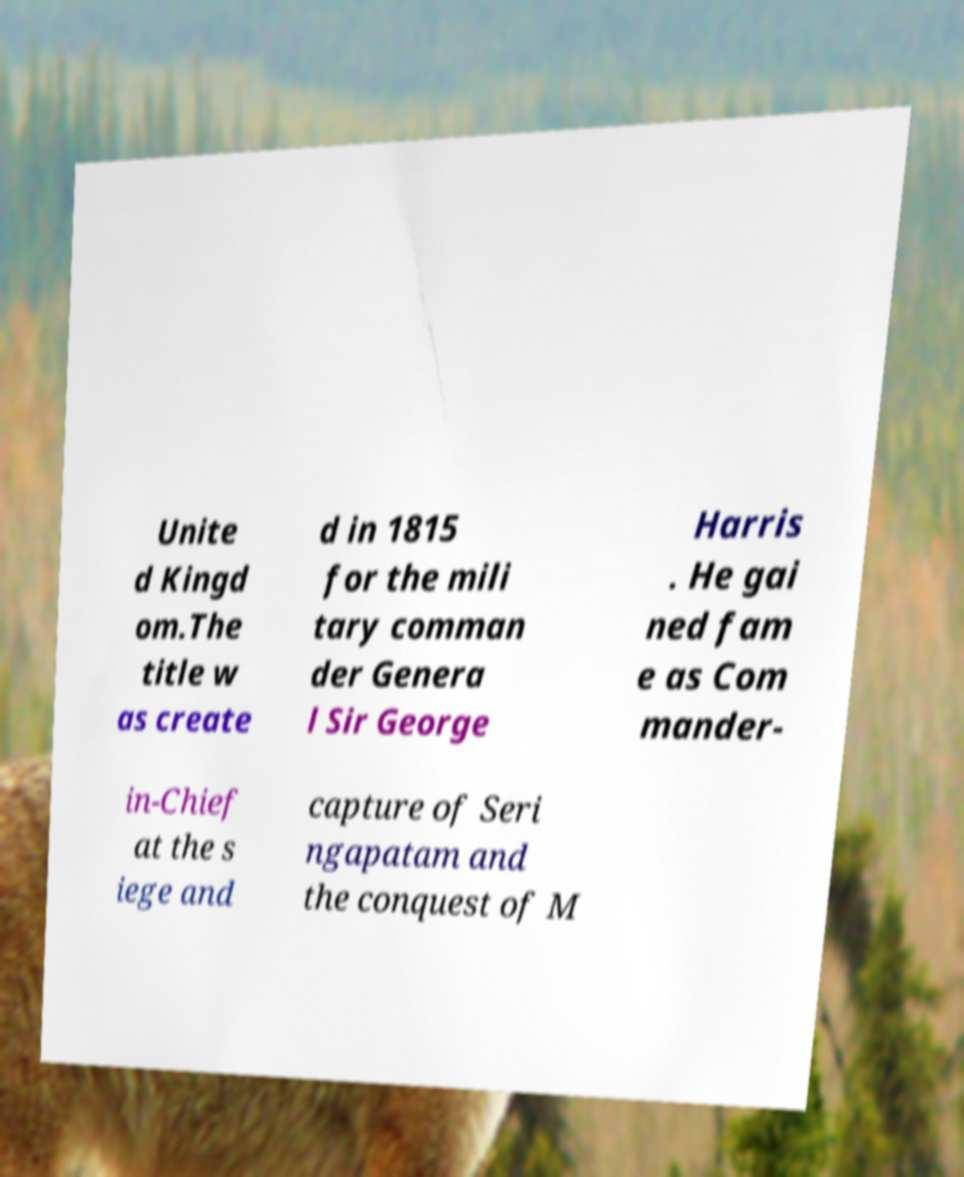What messages or text are displayed in this image? I need them in a readable, typed format. Unite d Kingd om.The title w as create d in 1815 for the mili tary comman der Genera l Sir George Harris . He gai ned fam e as Com mander- in-Chief at the s iege and capture of Seri ngapatam and the conquest of M 